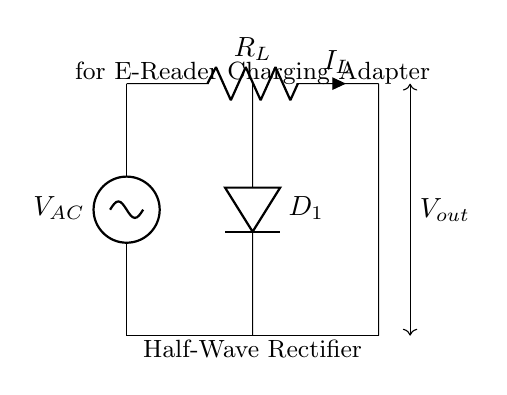What is the type of rectifier used? The circuit diagram specifically identifies it as a half-wave rectifier, as noted in the label. A half-wave rectifier allows only one half of the AC waveform to pass through, hence the designation.
Answer: half-wave rectifier What component is responsible for rectification? The diode (labeled D1) is the component responsible for rectification in this circuit. It allows current to flow in one direction, converting AC to DC.
Answer: diode What does R_L represent in the circuit? R_L represents the load resistor in the circuit. It is connected across the output to receive the current produced by the rectification process.
Answer: load resistor What is the output voltage of the circuit labeled as? The output voltage is denoted as V_out in the circuit diagram. This notation indicates the voltage that the load resistor R_L experiences as a result of the rectification.
Answer: V_out What happens to the AC voltage in this circuit? The AC voltage is converted to DC voltage by the action of the diode, which only allows the positive half of the AC cycle to pass through. This results in a pulsed DC output.
Answer: converted to DC Why is a half-wave rectifier used in e-reader charging? A half-wave rectifier is simpler and cheaper to implement, making it suitable for low-power devices like e-readers that do not require significant power or efficiency.
Answer: simplicity and cost-effectiveness 